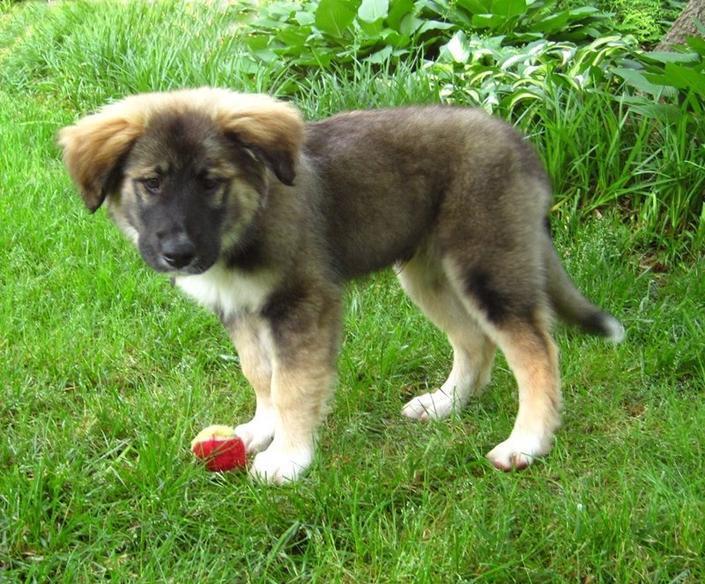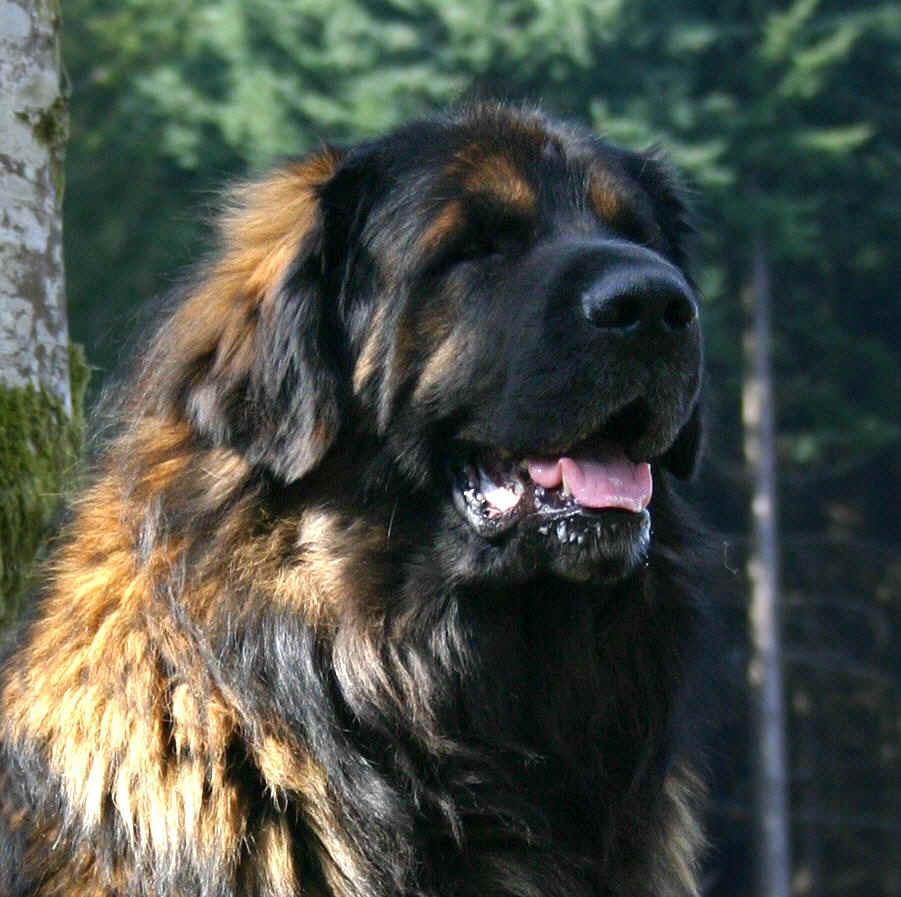The first image is the image on the left, the second image is the image on the right. Considering the images on both sides, is "All images show camera-facing dogs, and all dogs look similar in coloring and breed." valid? Answer yes or no. No. The first image is the image on the left, the second image is the image on the right. For the images shown, is this caption "There is only one dog in each image and it has its mouth open." true? Answer yes or no. No. 